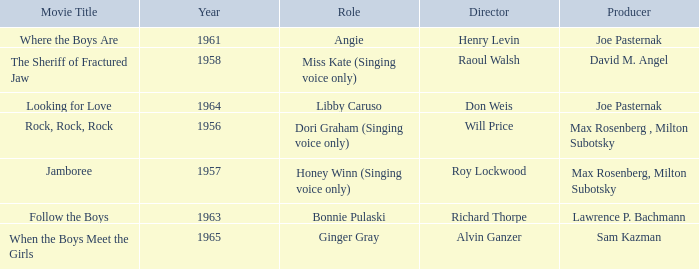What year was Sam Kazman a producer? 1965.0. 